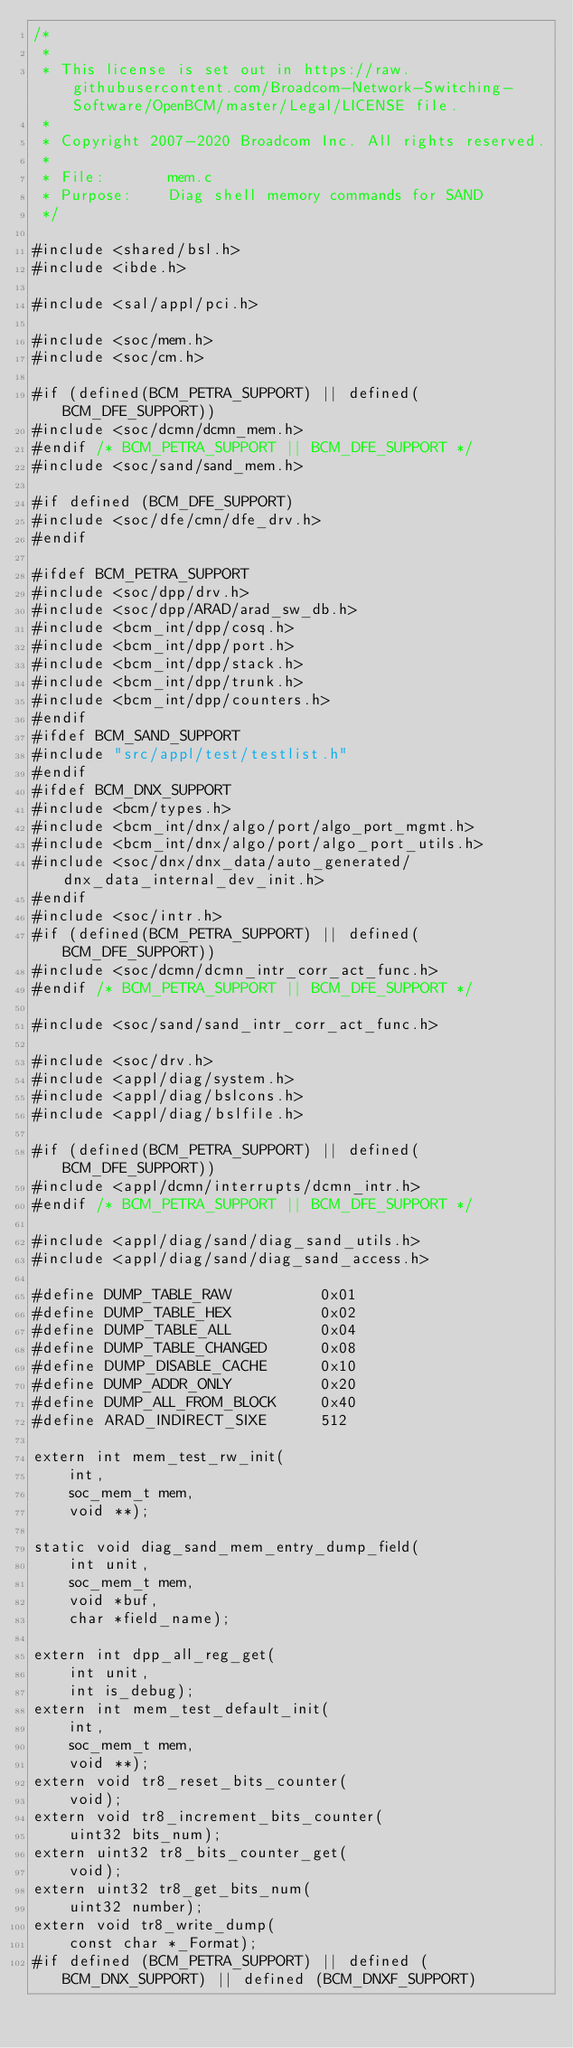<code> <loc_0><loc_0><loc_500><loc_500><_C_>/*
 * 
 * This license is set out in https://raw.githubusercontent.com/Broadcom-Network-Switching-Software/OpenBCM/master/Legal/LICENSE file.
 * 
 * Copyright 2007-2020 Broadcom Inc. All rights reserved.
 *
 * File:       mem.c
 * Purpose:    Diag shell memory commands for SAND
 */

#include <shared/bsl.h>
#include <ibde.h>

#include <sal/appl/pci.h>

#include <soc/mem.h>
#include <soc/cm.h>

#if (defined(BCM_PETRA_SUPPORT) || defined(BCM_DFE_SUPPORT))
#include <soc/dcmn/dcmn_mem.h>
#endif /* BCM_PETRA_SUPPORT || BCM_DFE_SUPPORT */
#include <soc/sand/sand_mem.h>

#if defined (BCM_DFE_SUPPORT)
#include <soc/dfe/cmn/dfe_drv.h>
#endif

#ifdef BCM_PETRA_SUPPORT
#include <soc/dpp/drv.h>
#include <soc/dpp/ARAD/arad_sw_db.h>
#include <bcm_int/dpp/cosq.h>
#include <bcm_int/dpp/port.h>
#include <bcm_int/dpp/stack.h>
#include <bcm_int/dpp/trunk.h>
#include <bcm_int/dpp/counters.h>
#endif
#ifdef BCM_SAND_SUPPORT
#include "src/appl/test/testlist.h"
#endif
#ifdef BCM_DNX_SUPPORT
#include <bcm/types.h>
#include <bcm_int/dnx/algo/port/algo_port_mgmt.h>
#include <bcm_int/dnx/algo/port/algo_port_utils.h>
#include <soc/dnx/dnx_data/auto_generated/dnx_data_internal_dev_init.h>
#endif
#include <soc/intr.h>
#if (defined(BCM_PETRA_SUPPORT) || defined(BCM_DFE_SUPPORT))
#include <soc/dcmn/dcmn_intr_corr_act_func.h>
#endif /* BCM_PETRA_SUPPORT || BCM_DFE_SUPPORT */

#include <soc/sand/sand_intr_corr_act_func.h>

#include <soc/drv.h>
#include <appl/diag/system.h>
#include <appl/diag/bslcons.h>
#include <appl/diag/bslfile.h>

#if (defined(BCM_PETRA_SUPPORT) || defined(BCM_DFE_SUPPORT))
#include <appl/dcmn/interrupts/dcmn_intr.h>
#endif /* BCM_PETRA_SUPPORT || BCM_DFE_SUPPORT */

#include <appl/diag/sand/diag_sand_utils.h>
#include <appl/diag/sand/diag_sand_access.h>

#define DUMP_TABLE_RAW          0x01
#define DUMP_TABLE_HEX          0x02
#define DUMP_TABLE_ALL          0x04
#define DUMP_TABLE_CHANGED      0x08
#define DUMP_DISABLE_CACHE      0x10
#define DUMP_ADDR_ONLY          0x20
#define DUMP_ALL_FROM_BLOCK     0x40
#define ARAD_INDIRECT_SIXE      512

extern int mem_test_rw_init(
    int,
    soc_mem_t mem,
    void **);

static void diag_sand_mem_entry_dump_field(
    int unit,
    soc_mem_t mem,
    void *buf,
    char *field_name);

extern int dpp_all_reg_get(
    int unit,
    int is_debug);
extern int mem_test_default_init(
    int,
    soc_mem_t mem,
    void **);
extern void tr8_reset_bits_counter(
    void);
extern void tr8_increment_bits_counter(
    uint32 bits_num);
extern uint32 tr8_bits_counter_get(
    void);
extern uint32 tr8_get_bits_num(
    uint32 number);
extern void tr8_write_dump(
    const char *_Format);
#if defined (BCM_PETRA_SUPPORT) || defined (BCM_DNX_SUPPORT) || defined (BCM_DNXF_SUPPORT)</code> 